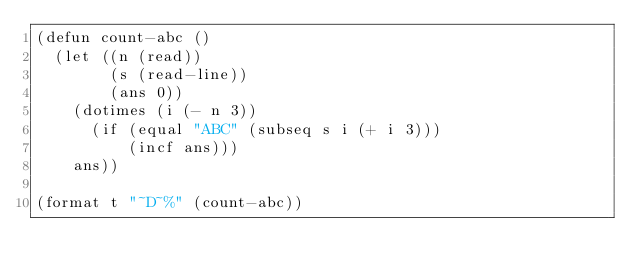<code> <loc_0><loc_0><loc_500><loc_500><_Lisp_>(defun count-abc ()
  (let ((n (read))
        (s (read-line))
        (ans 0))
    (dotimes (i (- n 3))
      (if (equal "ABC" (subseq s i (+ i 3)))
          (incf ans))) 
    ans)) 

(format t "~D~%" (count-abc)) 

</code> 